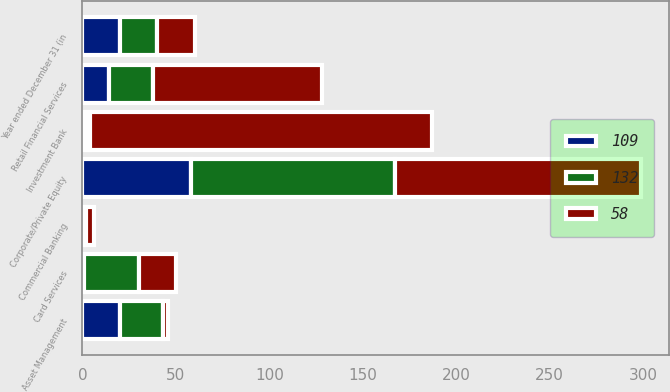Convert chart. <chart><loc_0><loc_0><loc_500><loc_500><stacked_bar_chart><ecel><fcel>Year ended December 31 (in<fcel>Investment Bank<fcel>Retail Financial Services<fcel>Card Services<fcel>Commercial Banking<fcel>Asset Management<fcel>Corporate/Private Equity<nl><fcel>58<fcel>20<fcel>183<fcel>90<fcel>20<fcel>4<fcel>3<fcel>132<nl><fcel>109<fcel>20<fcel>2<fcel>14<fcel>1<fcel>1<fcel>20<fcel>58<nl><fcel>132<fcel>20<fcel>2<fcel>24<fcel>29<fcel>1<fcel>23<fcel>109<nl></chart> 